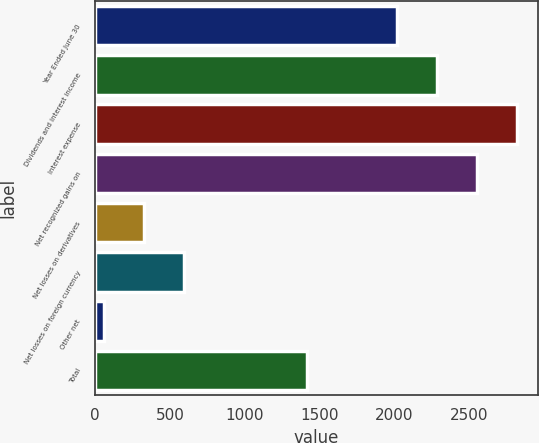<chart> <loc_0><loc_0><loc_500><loc_500><bar_chart><fcel>Year Ended June 30<fcel>Dividends and interest income<fcel>Interest expense<fcel>Net recognized gains on<fcel>Net losses on derivatives<fcel>Net losses on foreign currency<fcel>Other net<fcel>Total<nl><fcel>2018<fcel>2285.4<fcel>2820.2<fcel>2552.8<fcel>326.4<fcel>593.8<fcel>59<fcel>1416<nl></chart> 